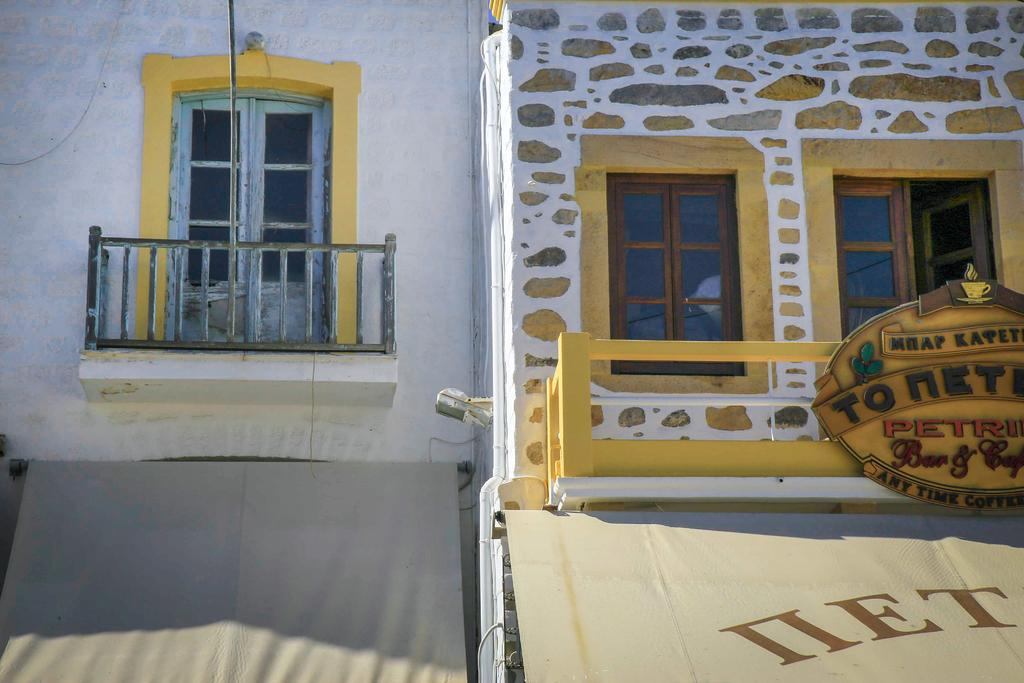How many buildings can be seen in the image? There are two buildings in the image. What is located at the bottom of the image? There are tents at the bottom of the image. What can be found in the center of the image? There are windows, a railing, and a hoarding in the center of the image. What is the purpose of the well in the image? The well is located at the top of the image, but its purpose cannot be determined from the image alone. Reasoning: Let' Let's think step by step in order to produce the conversation. We start by identifying the main subjects and objects in the image based on the provided facts. We then formulate questions that focus on the location and characteristics of these subjects and objects, ensuring that each question can be answered definitively with the information given. We avoid yes/no questions and ensure that the language is simple and clear. Absurd Question/Answer: How many units of coal are being transported by the group in the image? There is no group or coal present in the image; it features two buildings, tents, windows, a railing, a hoarding, and a well. How many units of coal are being transported by the group in the image? There is no group or coal present in the image; it features two buildings, tents, windows, a railing, a hoarding, and a well. 